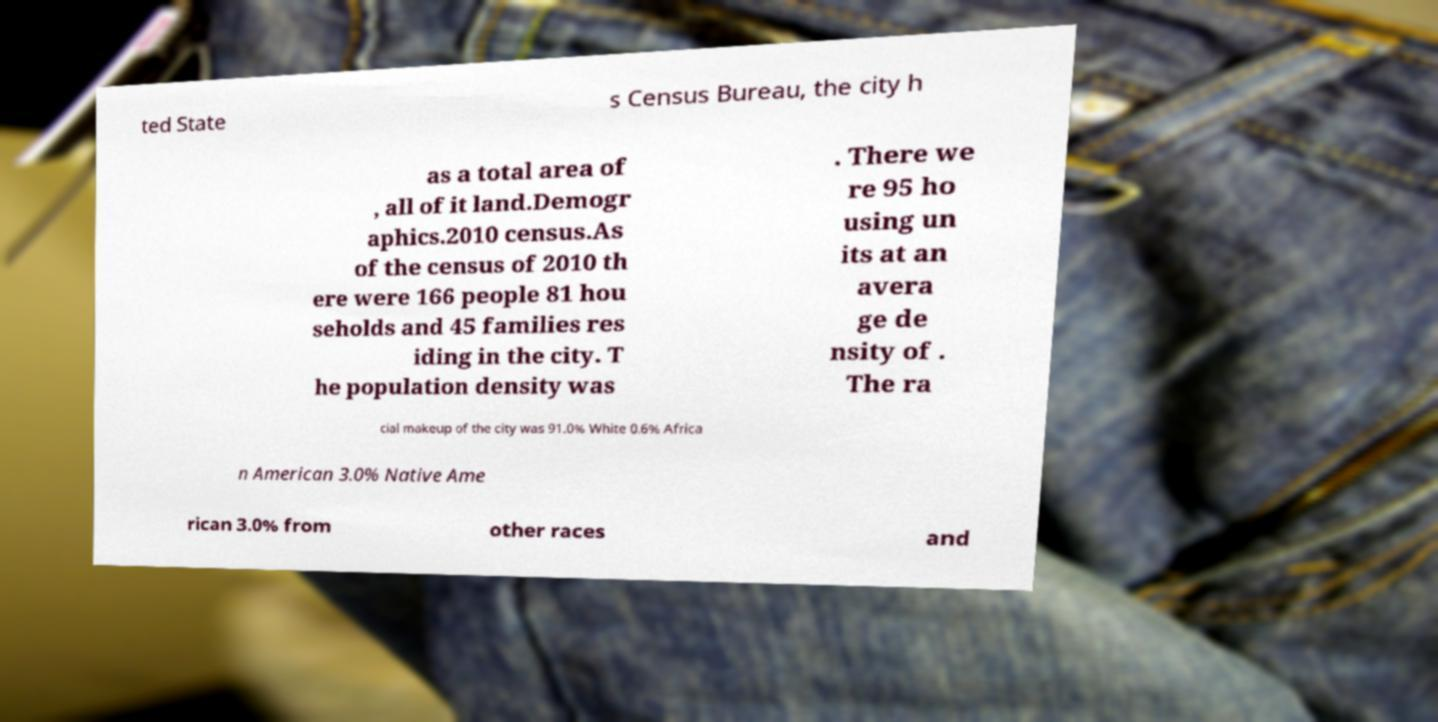Could you extract and type out the text from this image? ted State s Census Bureau, the city h as a total area of , all of it land.Demogr aphics.2010 census.As of the census of 2010 th ere were 166 people 81 hou seholds and 45 families res iding in the city. T he population density was . There we re 95 ho using un its at an avera ge de nsity of . The ra cial makeup of the city was 91.0% White 0.6% Africa n American 3.0% Native Ame rican 3.0% from other races and 